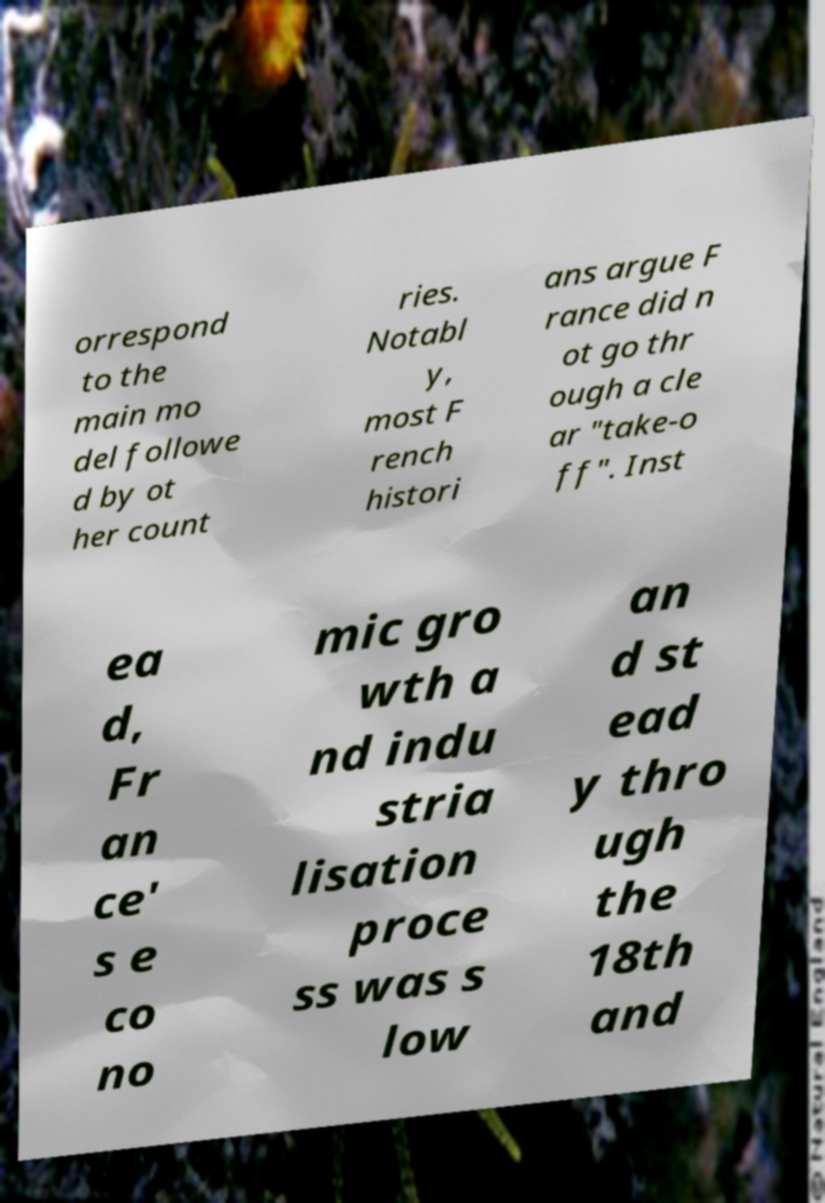I need the written content from this picture converted into text. Can you do that? orrespond to the main mo del followe d by ot her count ries. Notabl y, most F rench histori ans argue F rance did n ot go thr ough a cle ar "take-o ff". Inst ea d, Fr an ce' s e co no mic gro wth a nd indu stria lisation proce ss was s low an d st ead y thro ugh the 18th and 